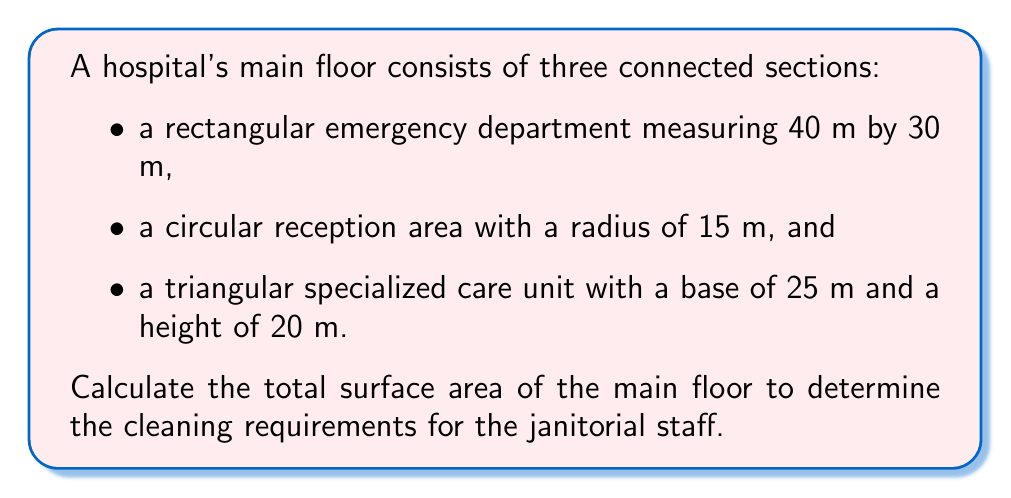Help me with this question. Let's break this down step-by-step:

1) For the rectangular emergency department:
   Area = length × width
   $A_{rectangle} = 40 \text{ m} \times 30 \text{ m} = 1200 \text{ m}^2$

2) For the circular reception area:
   Area = π × radius²
   $A_{circle} = \pi \times (15 \text{ m})^2 = 225\pi \text{ m}^2$

3) For the triangular specialized care unit:
   Area = $\frac{1}{2}$ × base × height
   $A_{triangle} = \frac{1}{2} \times 25 \text{ m} \times 20 \text{ m} = 250 \text{ m}^2$

4) Total surface area:
   $A_{total} = A_{rectangle} + A_{circle} + A_{triangle}$
   $A_{total} = 1200 \text{ m}^2 + 225\pi \text{ m}^2 + 250 \text{ m}^2$
   $A_{total} = 1450 + 225\pi \text{ m}^2$

5) Simplifying (using π ≈ 3.14159):
   $A_{total} \approx 1450 + 706.86 \text{ m}^2 = 2156.86 \text{ m}^2$
Answer: $2156.86 \text{ m}^2$ 